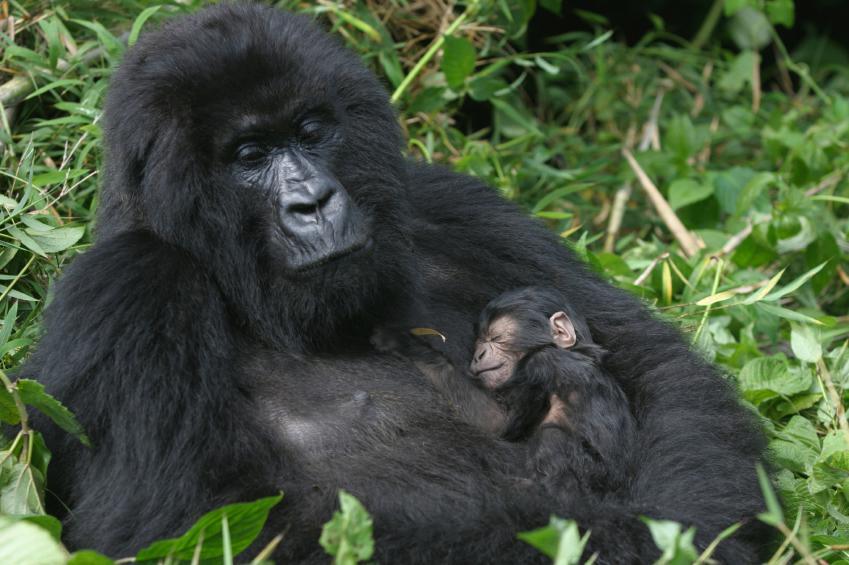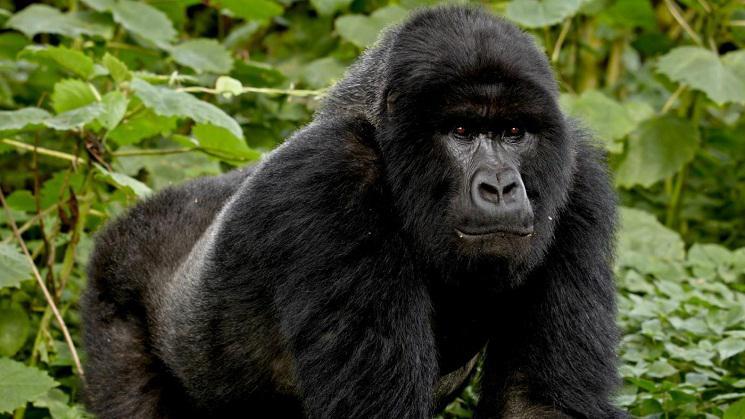The first image is the image on the left, the second image is the image on the right. For the images shown, is this caption "An image shows exactly one adult gorilla in close contact with a baby gorilla." true? Answer yes or no. Yes. The first image is the image on the left, the second image is the image on the right. Evaluate the accuracy of this statement regarding the images: "A single adult gorilla is holding a baby.". Is it true? Answer yes or no. Yes. 